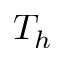Convert formula to latex. <formula><loc_0><loc_0><loc_500><loc_500>T _ { h }</formula> 